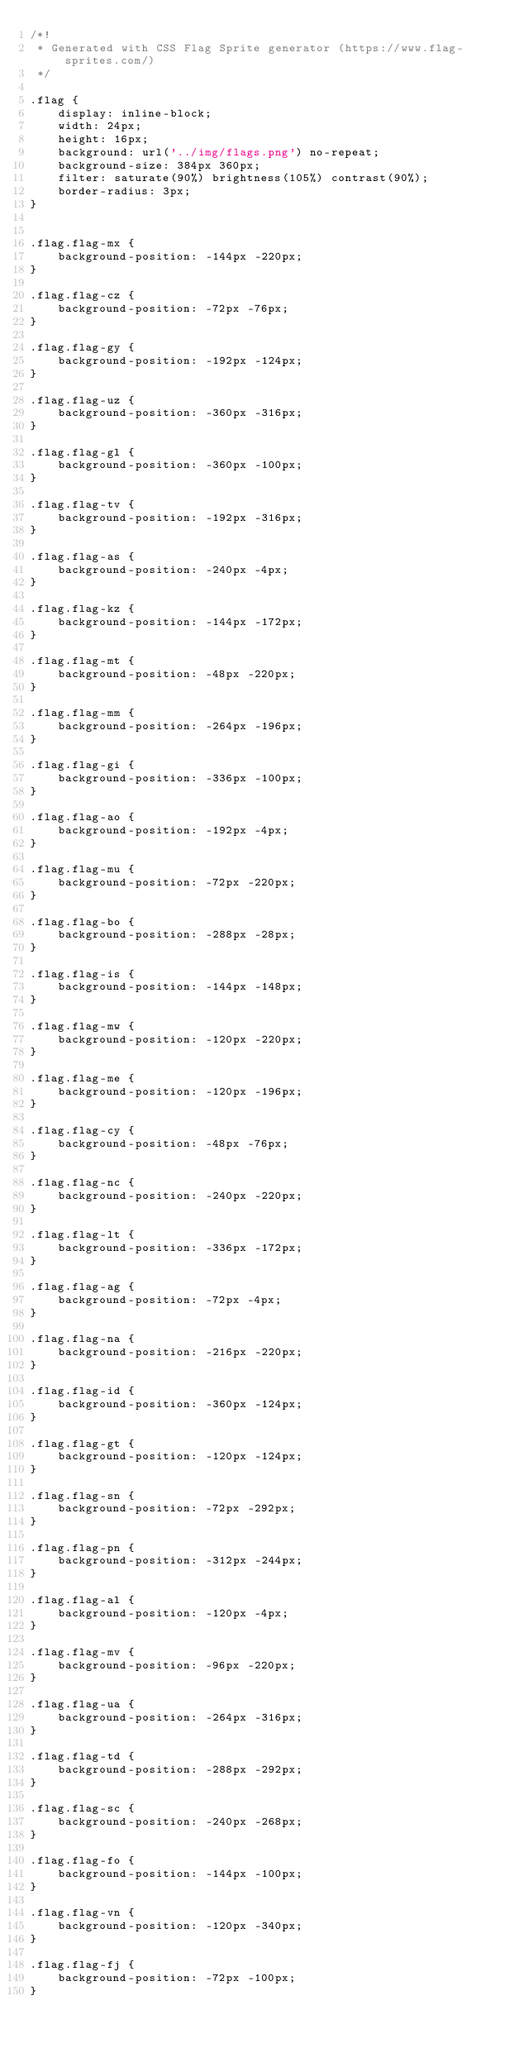<code> <loc_0><loc_0><loc_500><loc_500><_CSS_>/*!
 * Generated with CSS Flag Sprite generator (https://www.flag-sprites.com/)
 */

.flag {
    display: inline-block;
    width: 24px;
    height: 16px;
    background: url('../img/flags.png') no-repeat;
    background-size: 384px 360px;
    filter: saturate(90%) brightness(105%) contrast(90%);
    border-radius: 3px;
}


.flag.flag-mx {
    background-position: -144px -220px;
}

.flag.flag-cz {
    background-position: -72px -76px;
}

.flag.flag-gy {
    background-position: -192px -124px;
}

.flag.flag-uz {
    background-position: -360px -316px;
}

.flag.flag-gl {
    background-position: -360px -100px;
}

.flag.flag-tv {
    background-position: -192px -316px;
}

.flag.flag-as {
    background-position: -240px -4px;
}

.flag.flag-kz {
    background-position: -144px -172px;
}

.flag.flag-mt {
    background-position: -48px -220px;
}

.flag.flag-mm {
    background-position: -264px -196px;
}

.flag.flag-gi {
    background-position: -336px -100px;
}

.flag.flag-ao {
    background-position: -192px -4px;
}

.flag.flag-mu {
    background-position: -72px -220px;
}

.flag.flag-bo {
    background-position: -288px -28px;
}

.flag.flag-is {
    background-position: -144px -148px;
}

.flag.flag-mw {
    background-position: -120px -220px;
}

.flag.flag-me {
    background-position: -120px -196px;
}

.flag.flag-cy {
    background-position: -48px -76px;
}

.flag.flag-nc {
    background-position: -240px -220px;
}

.flag.flag-lt {
    background-position: -336px -172px;
}

.flag.flag-ag {
    background-position: -72px -4px;
}

.flag.flag-na {
    background-position: -216px -220px;
}

.flag.flag-id {
    background-position: -360px -124px;
}

.flag.flag-gt {
    background-position: -120px -124px;
}

.flag.flag-sn {
    background-position: -72px -292px;
}

.flag.flag-pn {
    background-position: -312px -244px;
}

.flag.flag-al {
    background-position: -120px -4px;
}

.flag.flag-mv {
    background-position: -96px -220px;
}

.flag.flag-ua {
    background-position: -264px -316px;
}

.flag.flag-td {
    background-position: -288px -292px;
}

.flag.flag-sc {
    background-position: -240px -268px;
}

.flag.flag-fo {
    background-position: -144px -100px;
}

.flag.flag-vn {
    background-position: -120px -340px;
}

.flag.flag-fj {
    background-position: -72px -100px;
}
</code> 